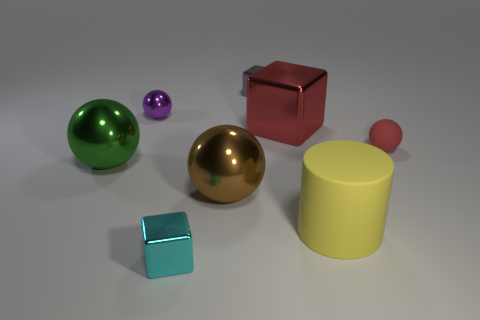Are there any metal blocks of the same color as the small matte ball?
Provide a short and direct response. Yes. What size is the brown ball that is made of the same material as the green ball?
Keep it short and to the point. Large. The rubber object that is the same color as the big cube is what size?
Ensure brevity in your answer.  Small. How many other objects are there of the same size as the yellow rubber object?
Give a very brief answer. 3. What material is the small ball right of the yellow matte thing?
Your response must be concise. Rubber. Does the purple shiny thing have the same size as the brown object?
Give a very brief answer. No. How many things are small metal blocks behind the tiny purple thing or small metal balls?
Your response must be concise. 2. There is a shiny sphere that is behind the red matte ball; how big is it?
Make the answer very short. Small. There is a brown metal ball; is its size the same as the ball on the left side of the purple ball?
Offer a very short reply. Yes. The tiny metal object in front of the metal thing that is on the right side of the gray cube is what color?
Keep it short and to the point. Cyan. 